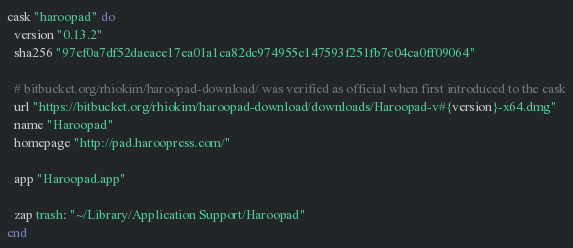<code> <loc_0><loc_0><loc_500><loc_500><_Ruby_>cask "haroopad" do
  version "0.13.2"
  sha256 "97ef0a7df52daeace17ea01a1ca82dc974955c147593f251fb7c04ca0ff09064"

  # bitbucket.org/rhiokim/haroopad-download/ was verified as official when first introduced to the cask
  url "https://bitbucket.org/rhiokim/haroopad-download/downloads/Haroopad-v#{version}-x64.dmg"
  name "Haroopad"
  homepage "http://pad.haroopress.com/"

  app "Haroopad.app"

  zap trash: "~/Library/Application Support/Haroopad"
end
</code> 